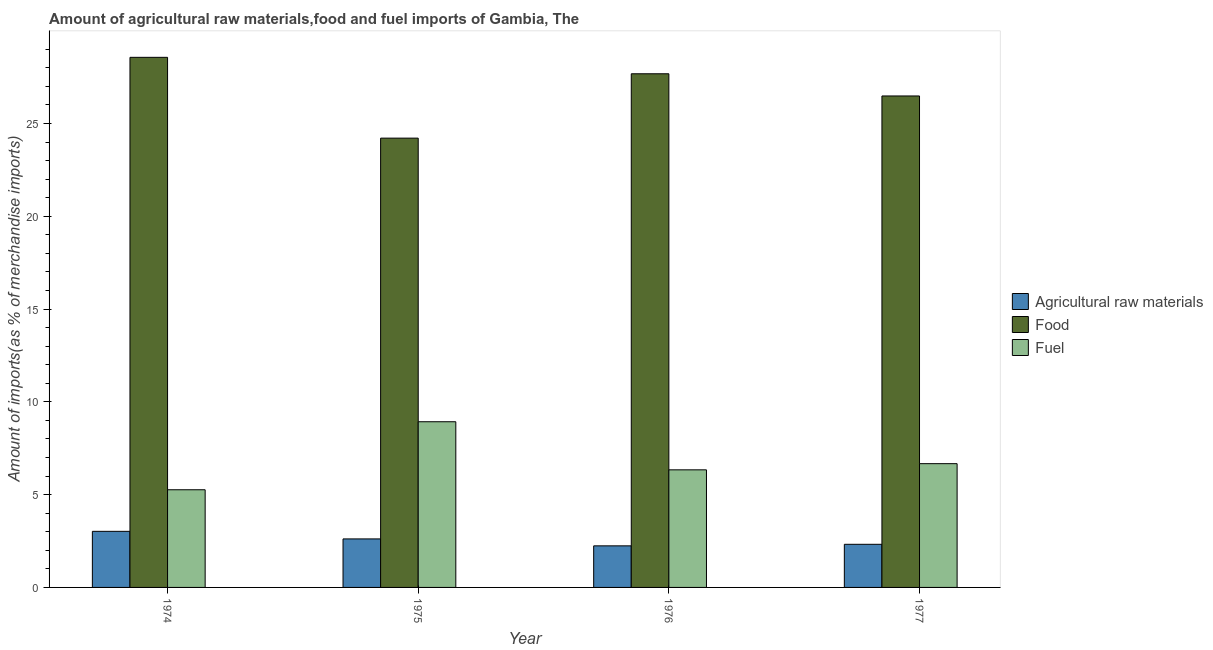How many groups of bars are there?
Keep it short and to the point. 4. Are the number of bars on each tick of the X-axis equal?
Provide a short and direct response. Yes. How many bars are there on the 2nd tick from the right?
Provide a short and direct response. 3. What is the percentage of raw materials imports in 1975?
Offer a terse response. 2.61. Across all years, what is the maximum percentage of raw materials imports?
Make the answer very short. 3.02. Across all years, what is the minimum percentage of food imports?
Offer a terse response. 24.21. In which year was the percentage of raw materials imports maximum?
Give a very brief answer. 1974. In which year was the percentage of food imports minimum?
Provide a succinct answer. 1975. What is the total percentage of food imports in the graph?
Give a very brief answer. 106.93. What is the difference between the percentage of fuel imports in 1975 and that in 1976?
Give a very brief answer. 2.59. What is the difference between the percentage of food imports in 1975 and the percentage of raw materials imports in 1976?
Offer a very short reply. -3.47. What is the average percentage of raw materials imports per year?
Keep it short and to the point. 2.55. In how many years, is the percentage of raw materials imports greater than 26 %?
Provide a short and direct response. 0. What is the ratio of the percentage of raw materials imports in 1976 to that in 1977?
Offer a terse response. 0.96. Is the percentage of raw materials imports in 1976 less than that in 1977?
Provide a short and direct response. Yes. Is the difference between the percentage of raw materials imports in 1975 and 1976 greater than the difference between the percentage of food imports in 1975 and 1976?
Provide a succinct answer. No. What is the difference between the highest and the second highest percentage of raw materials imports?
Offer a terse response. 0.41. What is the difference between the highest and the lowest percentage of fuel imports?
Your answer should be compact. 3.66. In how many years, is the percentage of fuel imports greater than the average percentage of fuel imports taken over all years?
Your response must be concise. 1. Is the sum of the percentage of fuel imports in 1975 and 1976 greater than the maximum percentage of raw materials imports across all years?
Offer a very short reply. Yes. What does the 3rd bar from the left in 1975 represents?
Provide a short and direct response. Fuel. What does the 3rd bar from the right in 1977 represents?
Make the answer very short. Agricultural raw materials. Is it the case that in every year, the sum of the percentage of raw materials imports and percentage of food imports is greater than the percentage of fuel imports?
Give a very brief answer. Yes. Are all the bars in the graph horizontal?
Provide a short and direct response. No. What is the difference between two consecutive major ticks on the Y-axis?
Provide a short and direct response. 5. Are the values on the major ticks of Y-axis written in scientific E-notation?
Give a very brief answer. No. Does the graph contain grids?
Provide a succinct answer. No. How many legend labels are there?
Provide a succinct answer. 3. What is the title of the graph?
Give a very brief answer. Amount of agricultural raw materials,food and fuel imports of Gambia, The. Does "Taxes on income" appear as one of the legend labels in the graph?
Give a very brief answer. No. What is the label or title of the X-axis?
Your response must be concise. Year. What is the label or title of the Y-axis?
Offer a very short reply. Amount of imports(as % of merchandise imports). What is the Amount of imports(as % of merchandise imports) of Agricultural raw materials in 1974?
Make the answer very short. 3.02. What is the Amount of imports(as % of merchandise imports) of Food in 1974?
Provide a succinct answer. 28.56. What is the Amount of imports(as % of merchandise imports) in Fuel in 1974?
Keep it short and to the point. 5.26. What is the Amount of imports(as % of merchandise imports) of Agricultural raw materials in 1975?
Keep it short and to the point. 2.61. What is the Amount of imports(as % of merchandise imports) of Food in 1975?
Keep it short and to the point. 24.21. What is the Amount of imports(as % of merchandise imports) of Fuel in 1975?
Provide a succinct answer. 8.93. What is the Amount of imports(as % of merchandise imports) of Agricultural raw materials in 1976?
Your answer should be very brief. 2.24. What is the Amount of imports(as % of merchandise imports) of Food in 1976?
Keep it short and to the point. 27.68. What is the Amount of imports(as % of merchandise imports) in Fuel in 1976?
Offer a very short reply. 6.34. What is the Amount of imports(as % of merchandise imports) in Agricultural raw materials in 1977?
Your response must be concise. 2.32. What is the Amount of imports(as % of merchandise imports) in Food in 1977?
Give a very brief answer. 26.48. What is the Amount of imports(as % of merchandise imports) of Fuel in 1977?
Keep it short and to the point. 6.67. Across all years, what is the maximum Amount of imports(as % of merchandise imports) in Agricultural raw materials?
Provide a succinct answer. 3.02. Across all years, what is the maximum Amount of imports(as % of merchandise imports) of Food?
Your response must be concise. 28.56. Across all years, what is the maximum Amount of imports(as % of merchandise imports) in Fuel?
Give a very brief answer. 8.93. Across all years, what is the minimum Amount of imports(as % of merchandise imports) of Agricultural raw materials?
Your answer should be very brief. 2.24. Across all years, what is the minimum Amount of imports(as % of merchandise imports) in Food?
Your answer should be compact. 24.21. Across all years, what is the minimum Amount of imports(as % of merchandise imports) of Fuel?
Offer a terse response. 5.26. What is the total Amount of imports(as % of merchandise imports) of Agricultural raw materials in the graph?
Your answer should be very brief. 10.2. What is the total Amount of imports(as % of merchandise imports) in Food in the graph?
Ensure brevity in your answer.  106.93. What is the total Amount of imports(as % of merchandise imports) of Fuel in the graph?
Your response must be concise. 27.19. What is the difference between the Amount of imports(as % of merchandise imports) in Agricultural raw materials in 1974 and that in 1975?
Your response must be concise. 0.41. What is the difference between the Amount of imports(as % of merchandise imports) of Food in 1974 and that in 1975?
Make the answer very short. 4.35. What is the difference between the Amount of imports(as % of merchandise imports) of Fuel in 1974 and that in 1975?
Provide a short and direct response. -3.66. What is the difference between the Amount of imports(as % of merchandise imports) of Agricultural raw materials in 1974 and that in 1976?
Provide a succinct answer. 0.78. What is the difference between the Amount of imports(as % of merchandise imports) in Food in 1974 and that in 1976?
Offer a very short reply. 0.89. What is the difference between the Amount of imports(as % of merchandise imports) in Fuel in 1974 and that in 1976?
Your answer should be compact. -1.07. What is the difference between the Amount of imports(as % of merchandise imports) in Agricultural raw materials in 1974 and that in 1977?
Your answer should be very brief. 0.7. What is the difference between the Amount of imports(as % of merchandise imports) of Food in 1974 and that in 1977?
Make the answer very short. 2.08. What is the difference between the Amount of imports(as % of merchandise imports) in Fuel in 1974 and that in 1977?
Your response must be concise. -1.41. What is the difference between the Amount of imports(as % of merchandise imports) of Agricultural raw materials in 1975 and that in 1976?
Offer a very short reply. 0.37. What is the difference between the Amount of imports(as % of merchandise imports) in Food in 1975 and that in 1976?
Offer a terse response. -3.47. What is the difference between the Amount of imports(as % of merchandise imports) of Fuel in 1975 and that in 1976?
Your response must be concise. 2.59. What is the difference between the Amount of imports(as % of merchandise imports) of Agricultural raw materials in 1975 and that in 1977?
Provide a succinct answer. 0.29. What is the difference between the Amount of imports(as % of merchandise imports) in Food in 1975 and that in 1977?
Your response must be concise. -2.27. What is the difference between the Amount of imports(as % of merchandise imports) in Fuel in 1975 and that in 1977?
Your answer should be very brief. 2.26. What is the difference between the Amount of imports(as % of merchandise imports) of Agricultural raw materials in 1976 and that in 1977?
Provide a short and direct response. -0.08. What is the difference between the Amount of imports(as % of merchandise imports) in Food in 1976 and that in 1977?
Offer a terse response. 1.2. What is the difference between the Amount of imports(as % of merchandise imports) of Fuel in 1976 and that in 1977?
Offer a terse response. -0.33. What is the difference between the Amount of imports(as % of merchandise imports) of Agricultural raw materials in 1974 and the Amount of imports(as % of merchandise imports) of Food in 1975?
Give a very brief answer. -21.19. What is the difference between the Amount of imports(as % of merchandise imports) in Agricultural raw materials in 1974 and the Amount of imports(as % of merchandise imports) in Fuel in 1975?
Give a very brief answer. -5.91. What is the difference between the Amount of imports(as % of merchandise imports) of Food in 1974 and the Amount of imports(as % of merchandise imports) of Fuel in 1975?
Make the answer very short. 19.64. What is the difference between the Amount of imports(as % of merchandise imports) in Agricultural raw materials in 1974 and the Amount of imports(as % of merchandise imports) in Food in 1976?
Provide a short and direct response. -24.65. What is the difference between the Amount of imports(as % of merchandise imports) of Agricultural raw materials in 1974 and the Amount of imports(as % of merchandise imports) of Fuel in 1976?
Your response must be concise. -3.31. What is the difference between the Amount of imports(as % of merchandise imports) in Food in 1974 and the Amount of imports(as % of merchandise imports) in Fuel in 1976?
Provide a short and direct response. 22.23. What is the difference between the Amount of imports(as % of merchandise imports) of Agricultural raw materials in 1974 and the Amount of imports(as % of merchandise imports) of Food in 1977?
Your answer should be compact. -23.46. What is the difference between the Amount of imports(as % of merchandise imports) of Agricultural raw materials in 1974 and the Amount of imports(as % of merchandise imports) of Fuel in 1977?
Your answer should be compact. -3.65. What is the difference between the Amount of imports(as % of merchandise imports) in Food in 1974 and the Amount of imports(as % of merchandise imports) in Fuel in 1977?
Give a very brief answer. 21.89. What is the difference between the Amount of imports(as % of merchandise imports) in Agricultural raw materials in 1975 and the Amount of imports(as % of merchandise imports) in Food in 1976?
Make the answer very short. -25.06. What is the difference between the Amount of imports(as % of merchandise imports) in Agricultural raw materials in 1975 and the Amount of imports(as % of merchandise imports) in Fuel in 1976?
Provide a succinct answer. -3.72. What is the difference between the Amount of imports(as % of merchandise imports) of Food in 1975 and the Amount of imports(as % of merchandise imports) of Fuel in 1976?
Offer a very short reply. 17.87. What is the difference between the Amount of imports(as % of merchandise imports) in Agricultural raw materials in 1975 and the Amount of imports(as % of merchandise imports) in Food in 1977?
Your answer should be compact. -23.87. What is the difference between the Amount of imports(as % of merchandise imports) of Agricultural raw materials in 1975 and the Amount of imports(as % of merchandise imports) of Fuel in 1977?
Ensure brevity in your answer.  -4.05. What is the difference between the Amount of imports(as % of merchandise imports) of Food in 1975 and the Amount of imports(as % of merchandise imports) of Fuel in 1977?
Provide a succinct answer. 17.54. What is the difference between the Amount of imports(as % of merchandise imports) in Agricultural raw materials in 1976 and the Amount of imports(as % of merchandise imports) in Food in 1977?
Make the answer very short. -24.24. What is the difference between the Amount of imports(as % of merchandise imports) of Agricultural raw materials in 1976 and the Amount of imports(as % of merchandise imports) of Fuel in 1977?
Provide a short and direct response. -4.43. What is the difference between the Amount of imports(as % of merchandise imports) in Food in 1976 and the Amount of imports(as % of merchandise imports) in Fuel in 1977?
Keep it short and to the point. 21.01. What is the average Amount of imports(as % of merchandise imports) of Agricultural raw materials per year?
Offer a terse response. 2.55. What is the average Amount of imports(as % of merchandise imports) of Food per year?
Provide a short and direct response. 26.73. What is the average Amount of imports(as % of merchandise imports) of Fuel per year?
Your response must be concise. 6.8. In the year 1974, what is the difference between the Amount of imports(as % of merchandise imports) in Agricultural raw materials and Amount of imports(as % of merchandise imports) in Food?
Keep it short and to the point. -25.54. In the year 1974, what is the difference between the Amount of imports(as % of merchandise imports) of Agricultural raw materials and Amount of imports(as % of merchandise imports) of Fuel?
Give a very brief answer. -2.24. In the year 1974, what is the difference between the Amount of imports(as % of merchandise imports) of Food and Amount of imports(as % of merchandise imports) of Fuel?
Make the answer very short. 23.3. In the year 1975, what is the difference between the Amount of imports(as % of merchandise imports) of Agricultural raw materials and Amount of imports(as % of merchandise imports) of Food?
Offer a very short reply. -21.59. In the year 1975, what is the difference between the Amount of imports(as % of merchandise imports) of Agricultural raw materials and Amount of imports(as % of merchandise imports) of Fuel?
Make the answer very short. -6.31. In the year 1975, what is the difference between the Amount of imports(as % of merchandise imports) in Food and Amount of imports(as % of merchandise imports) in Fuel?
Offer a very short reply. 15.28. In the year 1976, what is the difference between the Amount of imports(as % of merchandise imports) of Agricultural raw materials and Amount of imports(as % of merchandise imports) of Food?
Offer a terse response. -25.44. In the year 1976, what is the difference between the Amount of imports(as % of merchandise imports) in Agricultural raw materials and Amount of imports(as % of merchandise imports) in Fuel?
Offer a terse response. -4.1. In the year 1976, what is the difference between the Amount of imports(as % of merchandise imports) in Food and Amount of imports(as % of merchandise imports) in Fuel?
Your answer should be very brief. 21.34. In the year 1977, what is the difference between the Amount of imports(as % of merchandise imports) of Agricultural raw materials and Amount of imports(as % of merchandise imports) of Food?
Offer a terse response. -24.16. In the year 1977, what is the difference between the Amount of imports(as % of merchandise imports) of Agricultural raw materials and Amount of imports(as % of merchandise imports) of Fuel?
Your answer should be very brief. -4.34. In the year 1977, what is the difference between the Amount of imports(as % of merchandise imports) in Food and Amount of imports(as % of merchandise imports) in Fuel?
Provide a succinct answer. 19.81. What is the ratio of the Amount of imports(as % of merchandise imports) of Agricultural raw materials in 1974 to that in 1975?
Provide a short and direct response. 1.16. What is the ratio of the Amount of imports(as % of merchandise imports) in Food in 1974 to that in 1975?
Provide a short and direct response. 1.18. What is the ratio of the Amount of imports(as % of merchandise imports) in Fuel in 1974 to that in 1975?
Offer a very short reply. 0.59. What is the ratio of the Amount of imports(as % of merchandise imports) of Agricultural raw materials in 1974 to that in 1976?
Offer a very short reply. 1.35. What is the ratio of the Amount of imports(as % of merchandise imports) in Food in 1974 to that in 1976?
Ensure brevity in your answer.  1.03. What is the ratio of the Amount of imports(as % of merchandise imports) of Fuel in 1974 to that in 1976?
Ensure brevity in your answer.  0.83. What is the ratio of the Amount of imports(as % of merchandise imports) of Agricultural raw materials in 1974 to that in 1977?
Give a very brief answer. 1.3. What is the ratio of the Amount of imports(as % of merchandise imports) in Food in 1974 to that in 1977?
Give a very brief answer. 1.08. What is the ratio of the Amount of imports(as % of merchandise imports) in Fuel in 1974 to that in 1977?
Ensure brevity in your answer.  0.79. What is the ratio of the Amount of imports(as % of merchandise imports) of Agricultural raw materials in 1975 to that in 1976?
Ensure brevity in your answer.  1.17. What is the ratio of the Amount of imports(as % of merchandise imports) in Food in 1975 to that in 1976?
Offer a terse response. 0.87. What is the ratio of the Amount of imports(as % of merchandise imports) in Fuel in 1975 to that in 1976?
Ensure brevity in your answer.  1.41. What is the ratio of the Amount of imports(as % of merchandise imports) of Agricultural raw materials in 1975 to that in 1977?
Offer a terse response. 1.12. What is the ratio of the Amount of imports(as % of merchandise imports) in Food in 1975 to that in 1977?
Your answer should be compact. 0.91. What is the ratio of the Amount of imports(as % of merchandise imports) in Fuel in 1975 to that in 1977?
Make the answer very short. 1.34. What is the ratio of the Amount of imports(as % of merchandise imports) in Agricultural raw materials in 1976 to that in 1977?
Offer a very short reply. 0.96. What is the ratio of the Amount of imports(as % of merchandise imports) of Food in 1976 to that in 1977?
Offer a terse response. 1.05. What is the ratio of the Amount of imports(as % of merchandise imports) in Fuel in 1976 to that in 1977?
Offer a terse response. 0.95. What is the difference between the highest and the second highest Amount of imports(as % of merchandise imports) in Agricultural raw materials?
Ensure brevity in your answer.  0.41. What is the difference between the highest and the second highest Amount of imports(as % of merchandise imports) of Food?
Provide a short and direct response. 0.89. What is the difference between the highest and the second highest Amount of imports(as % of merchandise imports) of Fuel?
Ensure brevity in your answer.  2.26. What is the difference between the highest and the lowest Amount of imports(as % of merchandise imports) in Agricultural raw materials?
Your response must be concise. 0.78. What is the difference between the highest and the lowest Amount of imports(as % of merchandise imports) in Food?
Your answer should be very brief. 4.35. What is the difference between the highest and the lowest Amount of imports(as % of merchandise imports) of Fuel?
Provide a short and direct response. 3.66. 